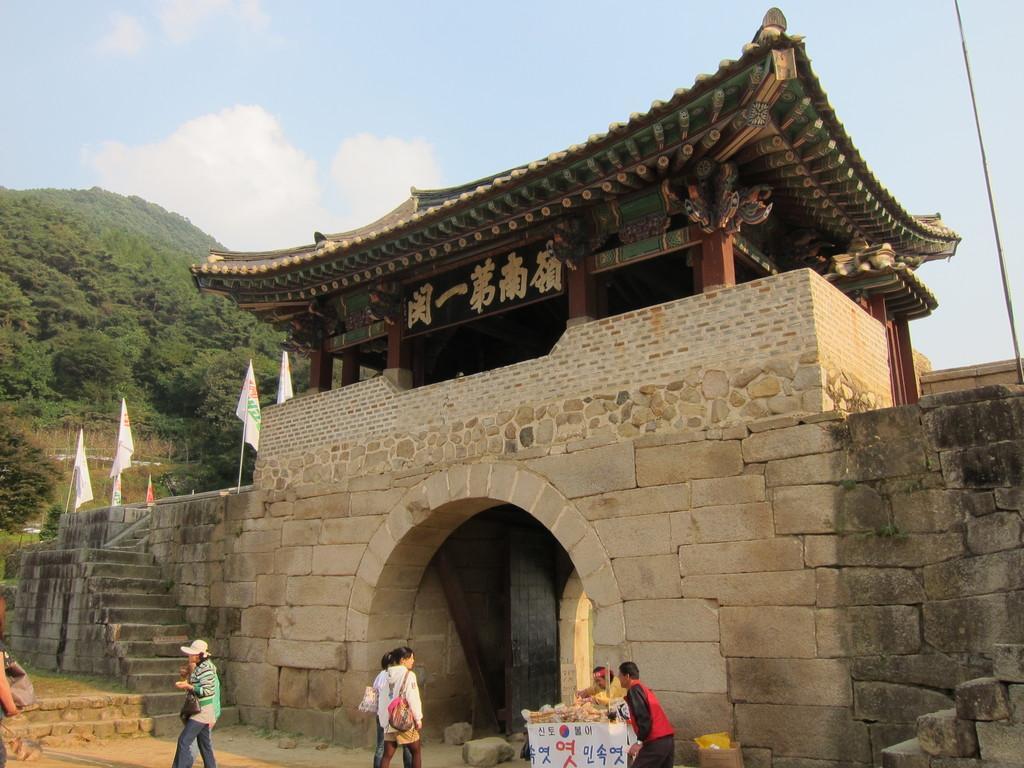How would you summarize this image in a sentence or two? This picture is clicked outside. In the foreground we can see the group of persons and there are some objects placed on the ground and we can see the stairway, flag and a building and we can see the text. In the background we can see the sky, hills and the grass. 